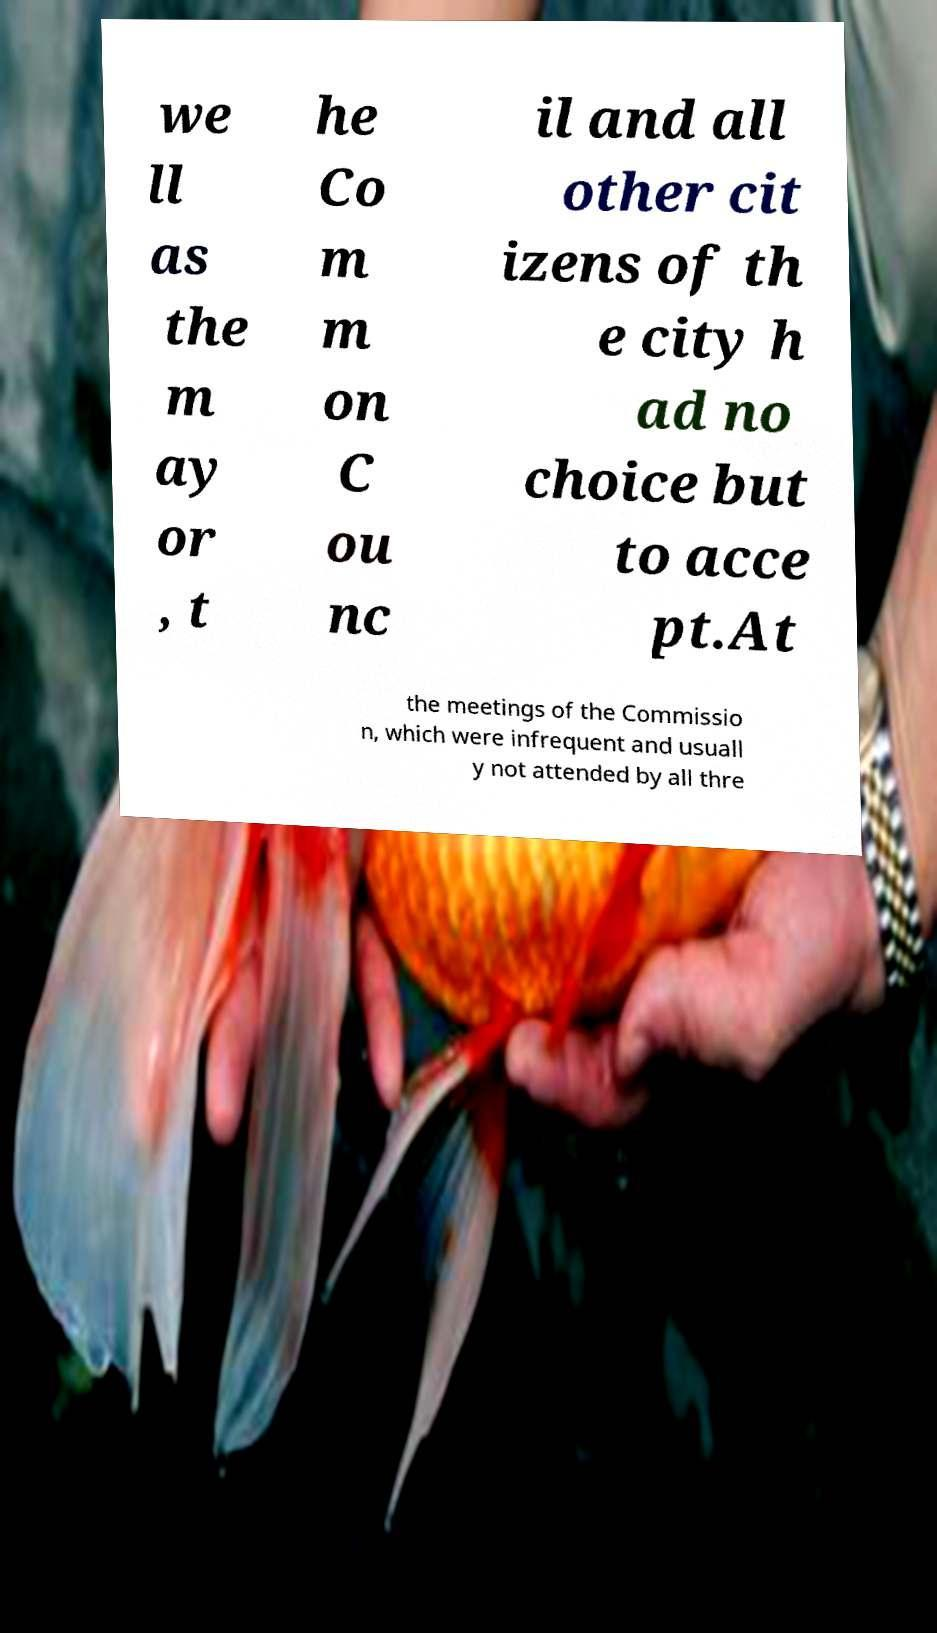I need the written content from this picture converted into text. Can you do that? we ll as the m ay or , t he Co m m on C ou nc il and all other cit izens of th e city h ad no choice but to acce pt.At the meetings of the Commissio n, which were infrequent and usuall y not attended by all thre 